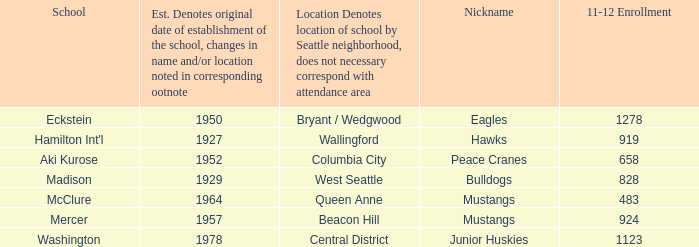Can you give me this table as a dict? {'header': ['School', 'Est. Denotes original date of establishment of the school, changes in name and/or location noted in corresponding ootnote', 'Location Denotes location of school by Seattle neighborhood, does not necessary correspond with attendance area', 'Nickname', '11-12 Enrollment'], 'rows': [['Eckstein', '1950', 'Bryant / Wedgwood', 'Eagles', '1278'], ["Hamilton Int'l", '1927', 'Wallingford', 'Hawks', '919'], ['Aki Kurose', '1952', 'Columbia City', 'Peace Cranes', '658'], ['Madison', '1929', 'West Seattle', 'Bulldogs', '828'], ['McClure', '1964', 'Queen Anne', 'Mustangs', '483'], ['Mercer', '1957', 'Beacon Hill', 'Mustangs', '924'], ['Washington', '1978', 'Central District', 'Junior Huskies', '1123']]} Specify the academic establishment in columbia city. Aki Kurose. 